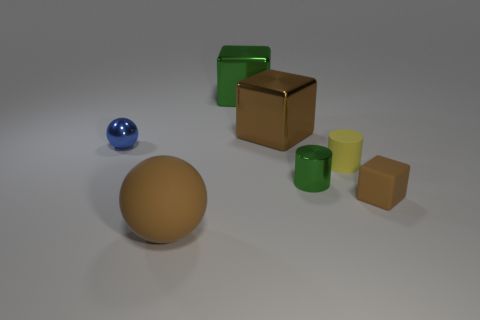Add 2 green objects. How many objects exist? 9 Subtract all cylinders. How many objects are left? 5 Add 7 tiny yellow cylinders. How many tiny yellow cylinders are left? 8 Add 3 big blue metallic blocks. How many big blue metallic blocks exist? 3 Subtract 1 blue spheres. How many objects are left? 6 Subtract all small brown things. Subtract all purple cylinders. How many objects are left? 6 